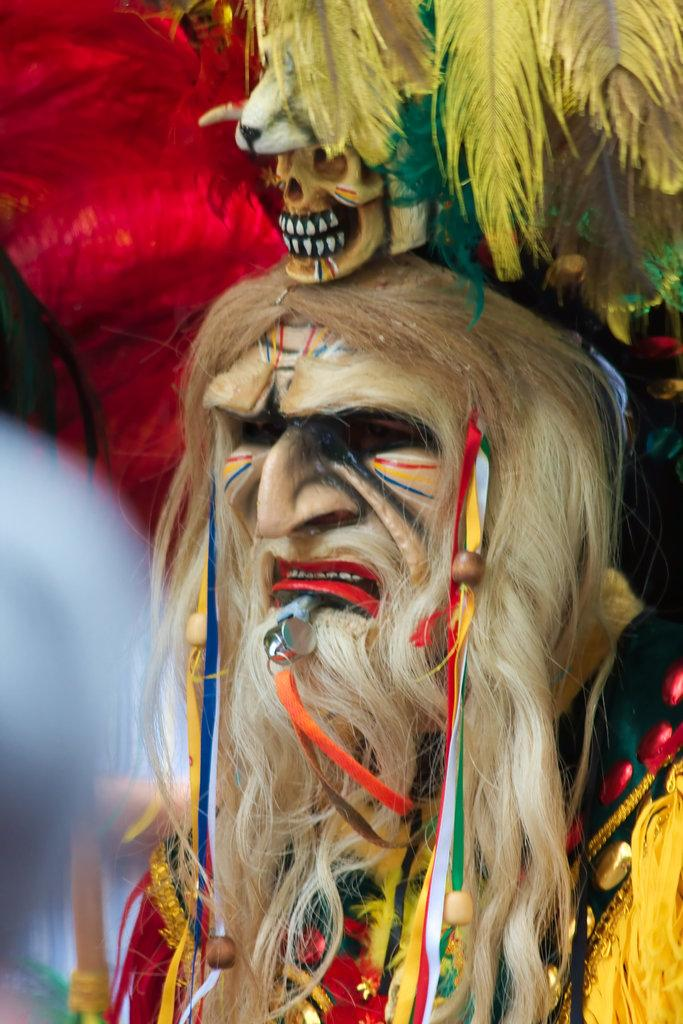What is the appearance of the person's hair in the image? The person has white hair in the image. What is on the person's face in the image? The person has paint on their face in the image. What type of hair accessory is the person wearing? The person has ribbon-like objects in their hair. What is on top of the person's head in the image? There is a skull on the person's head in the image. What type of grass is growing on the person's head in the image? There is no grass present on the person's head in the image; there is a skull. What emotion does the person seem to be experiencing in the image? The image does not convey any specific emotion, so it is not possible to determine if the person is experiencing shame or any other emotion. 